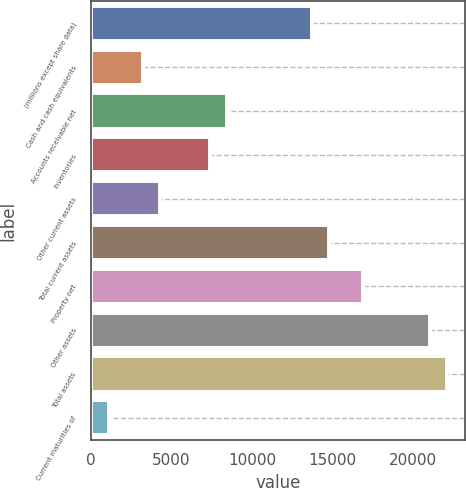Convert chart to OTSL. <chart><loc_0><loc_0><loc_500><loc_500><bar_chart><fcel>(millions except share data)<fcel>Cash and cash equivalents<fcel>Accounts receivable net<fcel>Inventories<fcel>Other current assets<fcel>Total current assets<fcel>Property net<fcel>Other assets<fcel>Total assets<fcel>Current maturities of<nl><fcel>13729.2<fcel>3213.58<fcel>8471.38<fcel>7419.82<fcel>4265.14<fcel>14780.7<fcel>16883.9<fcel>21090.1<fcel>22141.7<fcel>1110.46<nl></chart> 